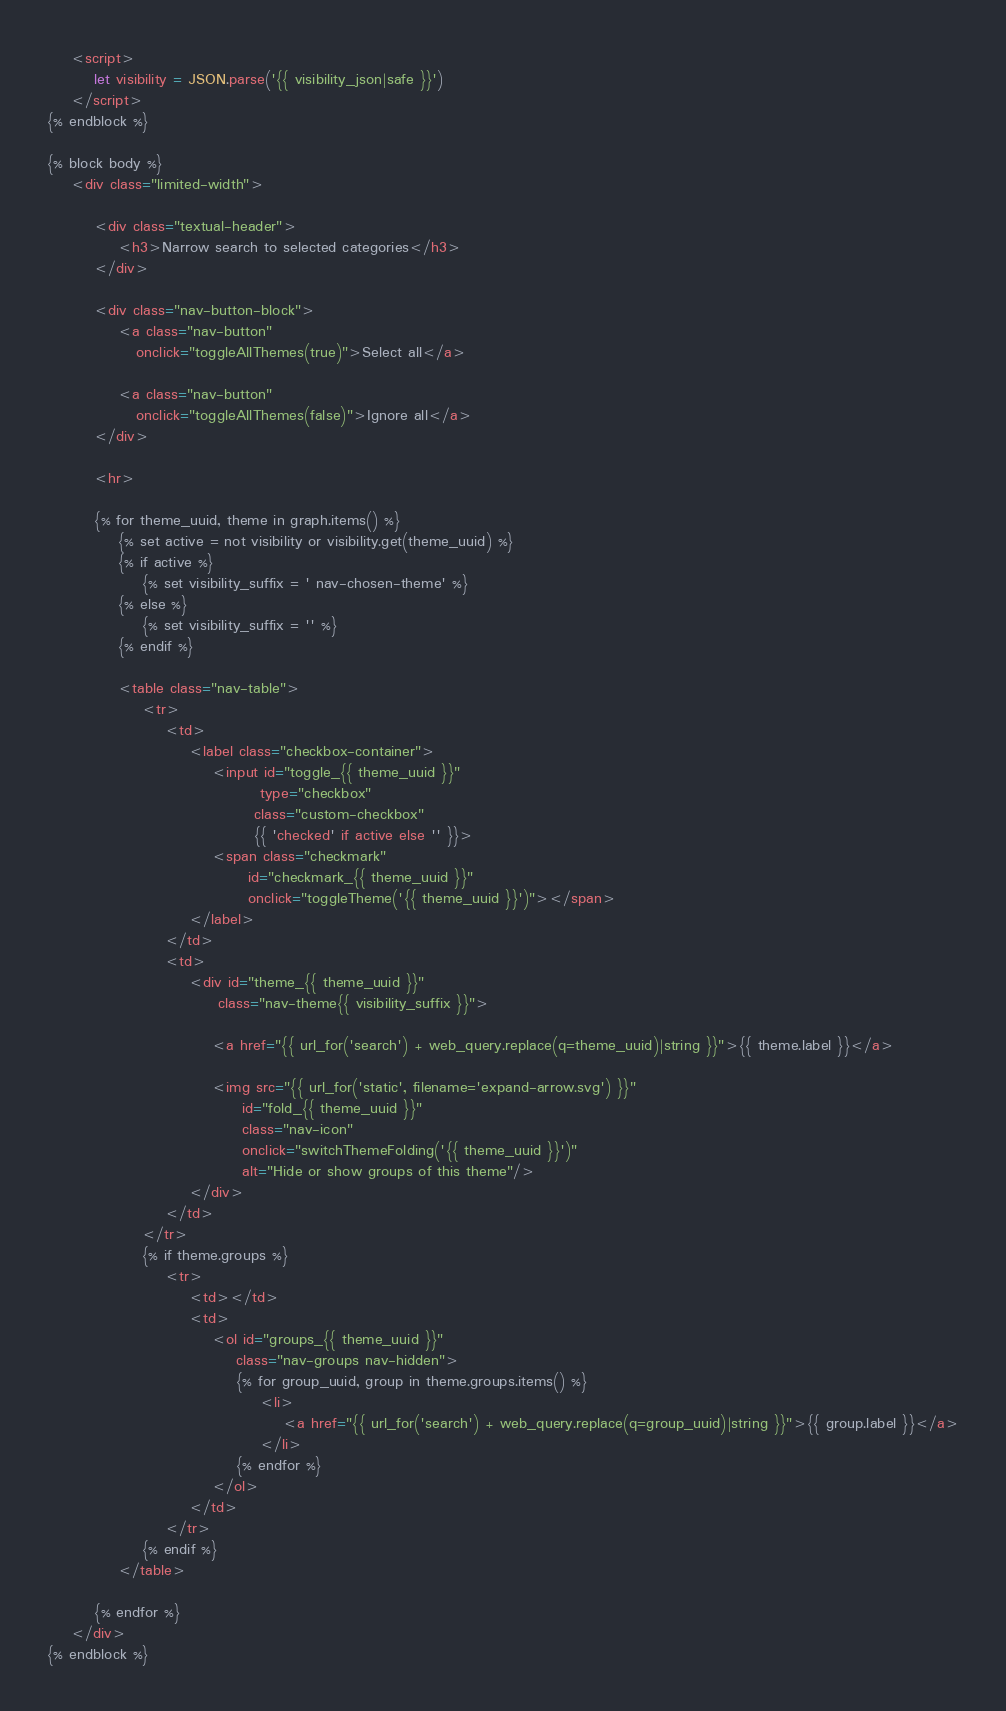<code> <loc_0><loc_0><loc_500><loc_500><_HTML_>    <script>
        let visibility = JSON.parse('{{ visibility_json|safe }}')
    </script>
{% endblock %}

{% block body %}
    <div class="limited-width">

        <div class="textual-header">
            <h3>Narrow search to selected categories</h3>
        </div>

        <div class="nav-button-block">
            <a class="nav-button"
               onclick="toggleAllThemes(true)">Select all</a>

            <a class="nav-button"
               onclick="toggleAllThemes(false)">Ignore all</a>
        </div>

        <hr>

        {% for theme_uuid, theme in graph.items() %}
            {% set active = not visibility or visibility.get(theme_uuid) %}
            {% if active %}
                {% set visibility_suffix = ' nav-chosen-theme' %}
            {% else %}
                {% set visibility_suffix = '' %}
            {% endif %}

            <table class="nav-table">
                <tr>
                    <td>
                        <label class="checkbox-container">
                            <input id="toggle_{{ theme_uuid }}"
                                    type="checkbox"
                                   class="custom-checkbox"
                                   {{ 'checked' if active else '' }}>
                            <span class="checkmark"
                                  id="checkmark_{{ theme_uuid }}"
                                  onclick="toggleTheme('{{ theme_uuid }}')"></span>
                        </label>
                    </td>
                    <td>
                        <div id="theme_{{ theme_uuid }}"
                             class="nav-theme{{ visibility_suffix }}">

                            <a href="{{ url_for('search') + web_query.replace(q=theme_uuid)|string }}">{{ theme.label }}</a>

                            <img src="{{ url_for('static', filename='expand-arrow.svg') }}"
                                 id="fold_{{ theme_uuid }}"
                                 class="nav-icon"
                                 onclick="switchThemeFolding('{{ theme_uuid }}')"
                                 alt="Hide or show groups of this theme"/>
                        </div>
                    </td>
                </tr>
                {% if theme.groups %}
                    <tr>
                        <td></td>
                        <td>
                            <ol id="groups_{{ theme_uuid }}"
                                class="nav-groups nav-hidden">
                                {% for group_uuid, group in theme.groups.items() %}
                                    <li>
                                        <a href="{{ url_for('search') + web_query.replace(q=group_uuid)|string }}">{{ group.label }}</a>
                                    </li>
                                {% endfor %}
                            </ol>
                        </td>
                    </tr>
                {% endif %}
            </table>

        {% endfor %}
    </div>
{% endblock %}</code> 